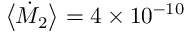Convert formula to latex. <formula><loc_0><loc_0><loc_500><loc_500>\left < \dot { M } _ { 2 } \right > = 4 \times 1 0 ^ { - 1 0 }</formula> 